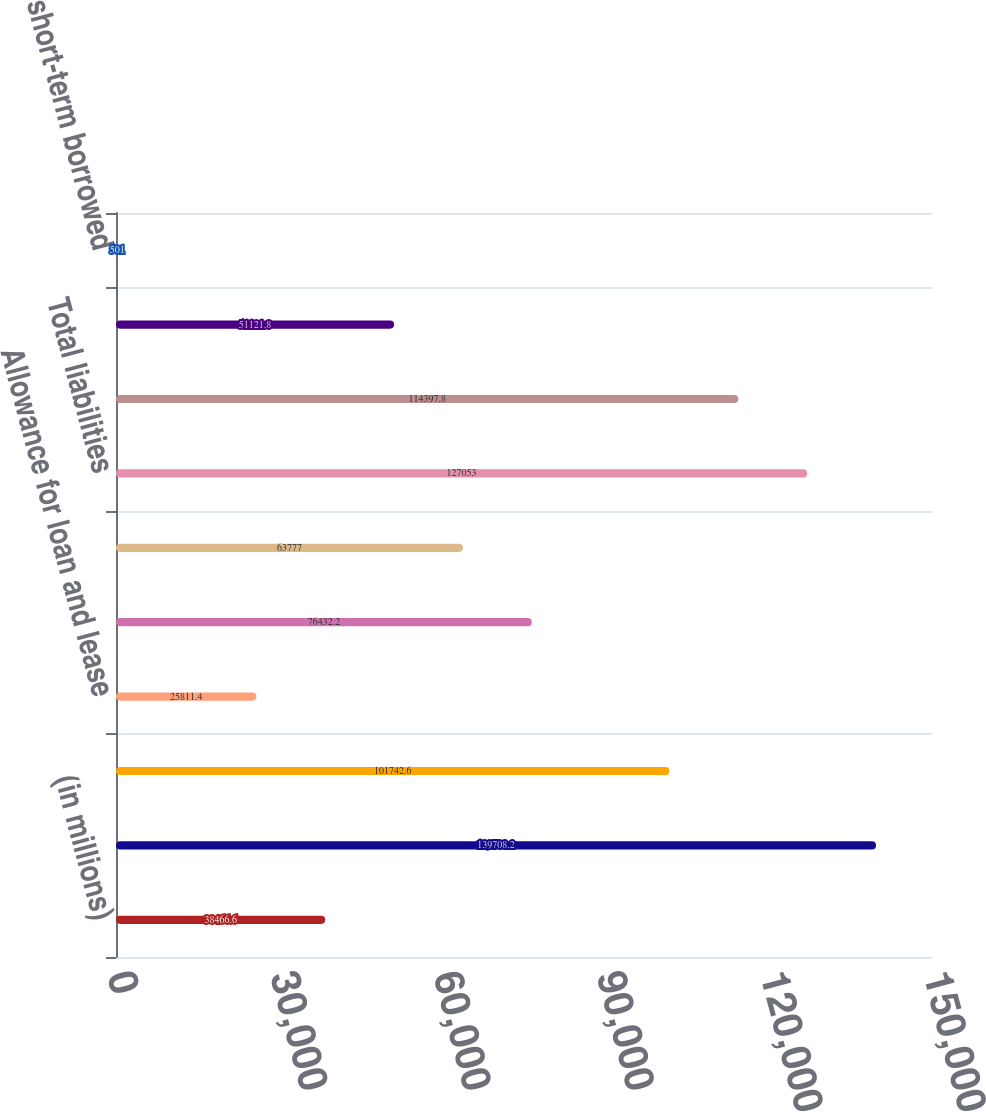<chart> <loc_0><loc_0><loc_500><loc_500><bar_chart><fcel>(in millions)<fcel>Total assets<fcel>Loans and leases (6)<fcel>Allowance for loan and lease<fcel>Total securities<fcel>Goodwill<fcel>Total liabilities<fcel>Total deposits (7)<fcel>Federal funds purchased and<fcel>Other short-term borrowed<nl><fcel>38466.6<fcel>139708<fcel>101743<fcel>25811.4<fcel>76432.2<fcel>63777<fcel>127053<fcel>114398<fcel>51121.8<fcel>501<nl></chart> 